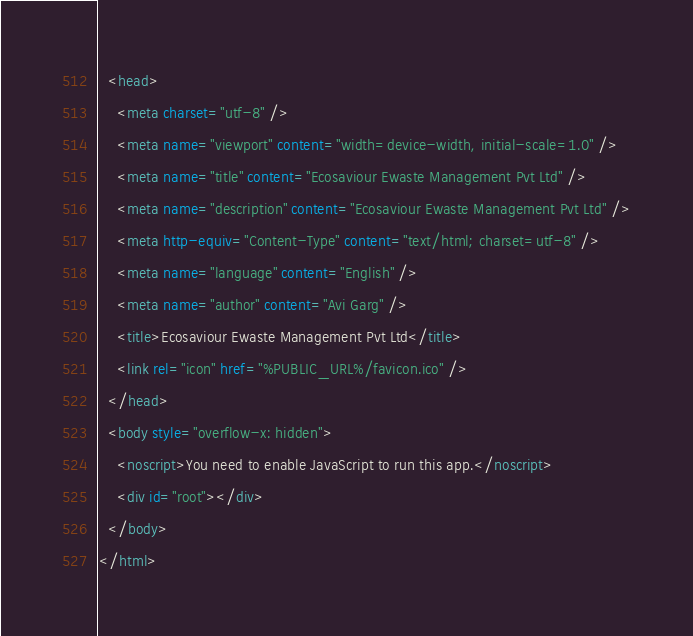Convert code to text. <code><loc_0><loc_0><loc_500><loc_500><_HTML_>  <head>
    <meta charset="utf-8" />
    <meta name="viewport" content="width=device-width, initial-scale=1.0" />
    <meta name="title" content="Ecosaviour Ewaste Management Pvt Ltd" />
    <meta name="description" content="Ecosaviour Ewaste Management Pvt Ltd" />
    <meta http-equiv="Content-Type" content="text/html; charset=utf-8" />
    <meta name="language" content="English" />
    <meta name="author" content="Avi Garg" />
    <title>Ecosaviour Ewaste Management Pvt Ltd</title>
    <link rel="icon" href="%PUBLIC_URL%/favicon.ico" />
  </head>
  <body style="overflow-x: hidden">
    <noscript>You need to enable JavaScript to run this app.</noscript>
    <div id="root"></div>
  </body>
</html>
</code> 